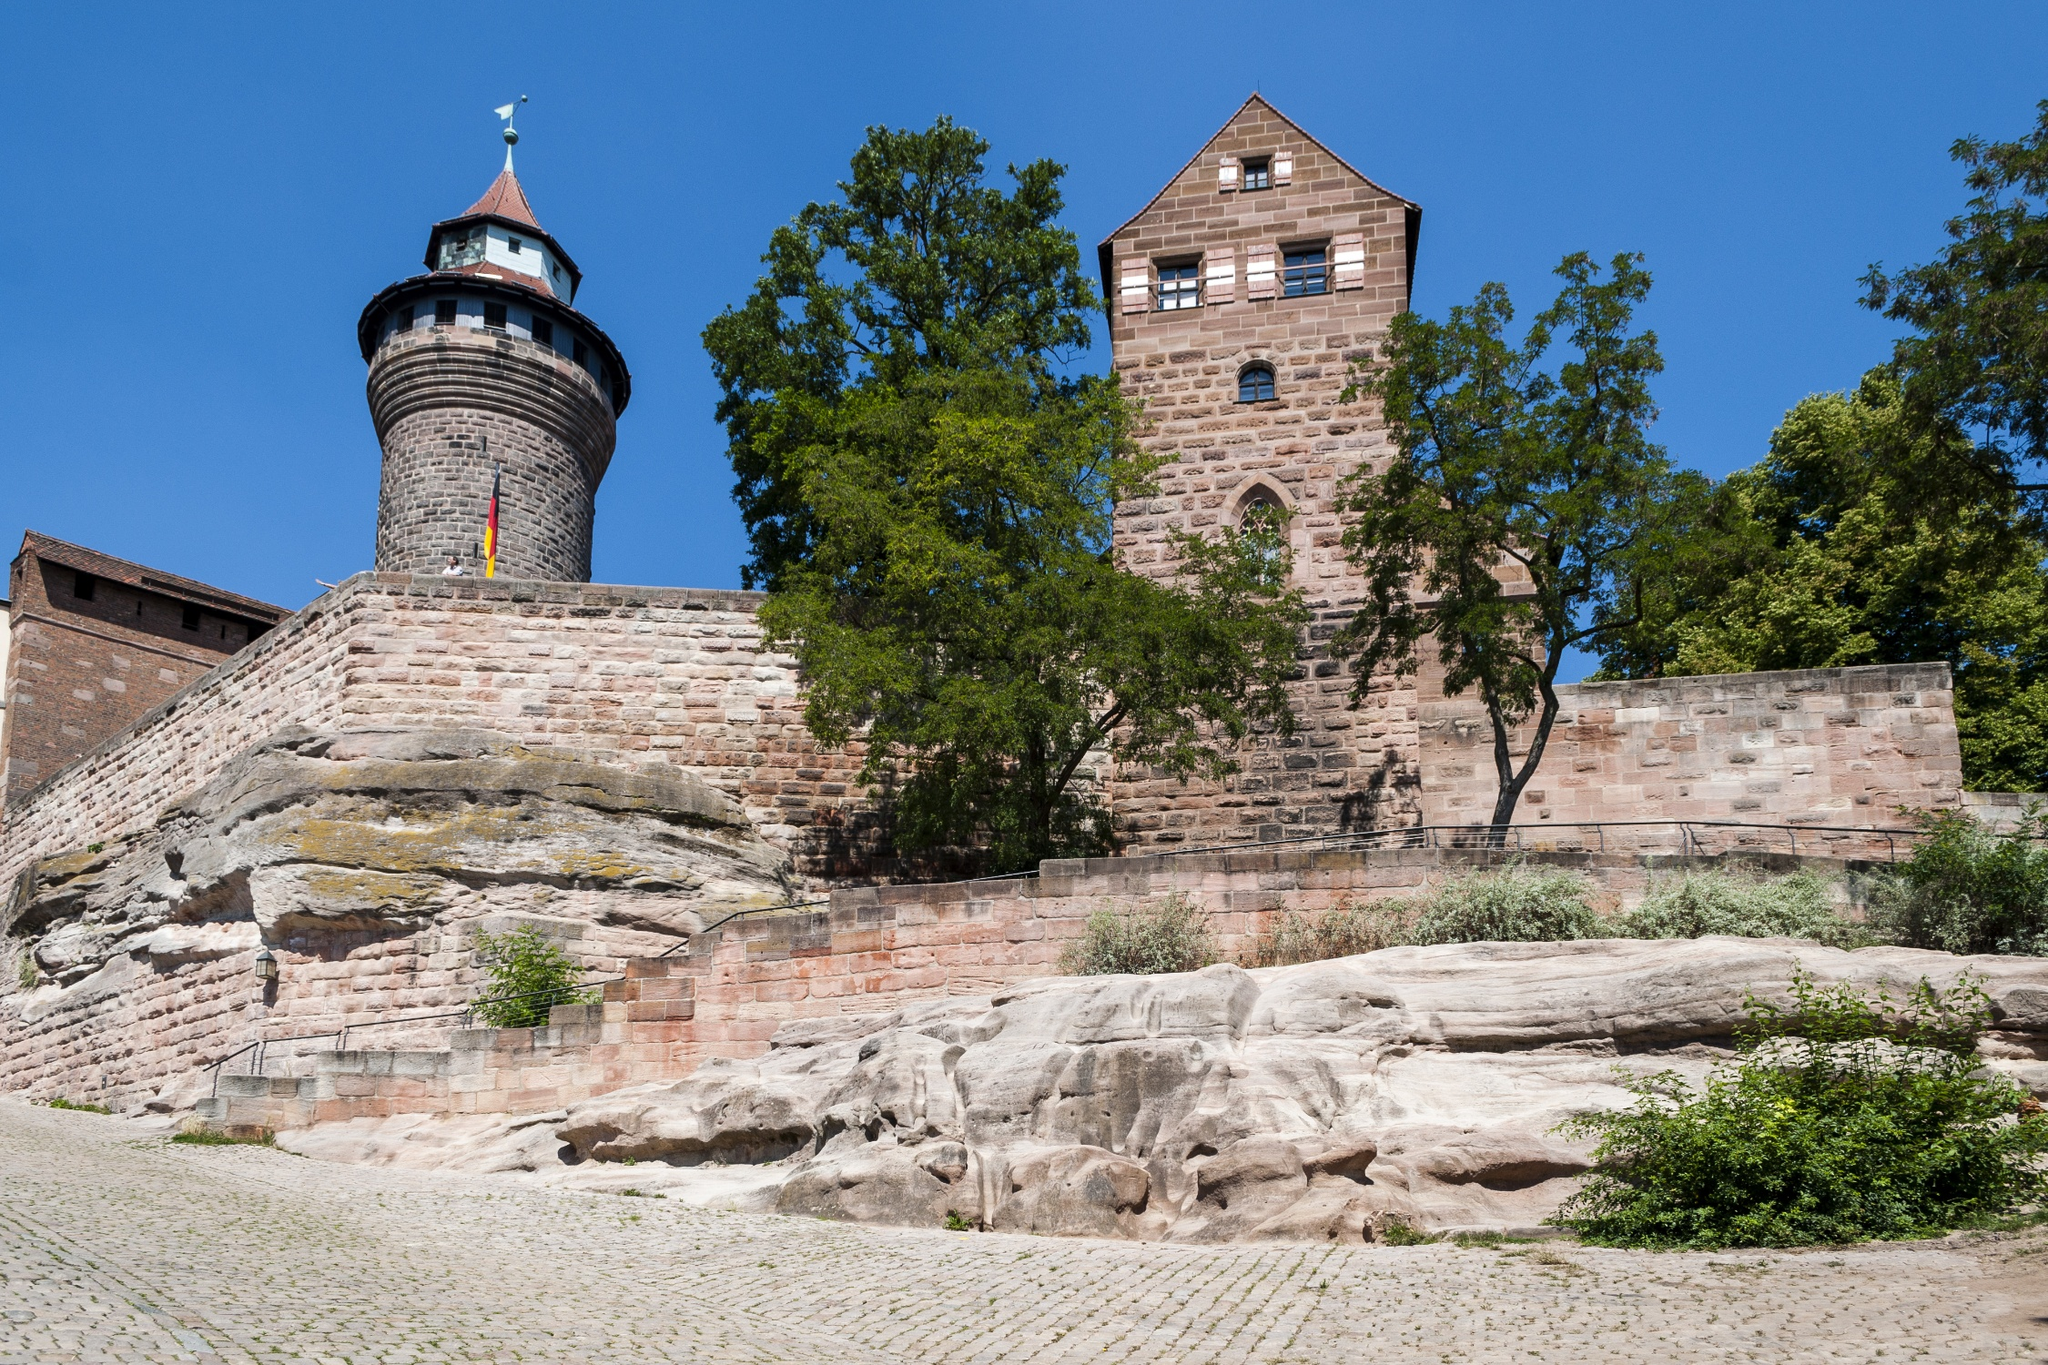Can you tell more about the historical significance of the Kaiserburg Nürnberg? Kaiserburg Nürnberg, or Nuremberg Castle, is deeply rooted in German history. It was one of the most important imperial castles of the Holy Roman Empire during the Middle Ages. Its construction dates back to around 1050, and for many centuries, it served as a residence for emperors of the Holy Roman Empire. The castle's location was strategic, offering both defense and a symbol of imperial power. Its rich history includes tales of sieges, royal stays, and significant historical events, including assemblies and courts that were fundamental in shaping the region's and Europe's history. 